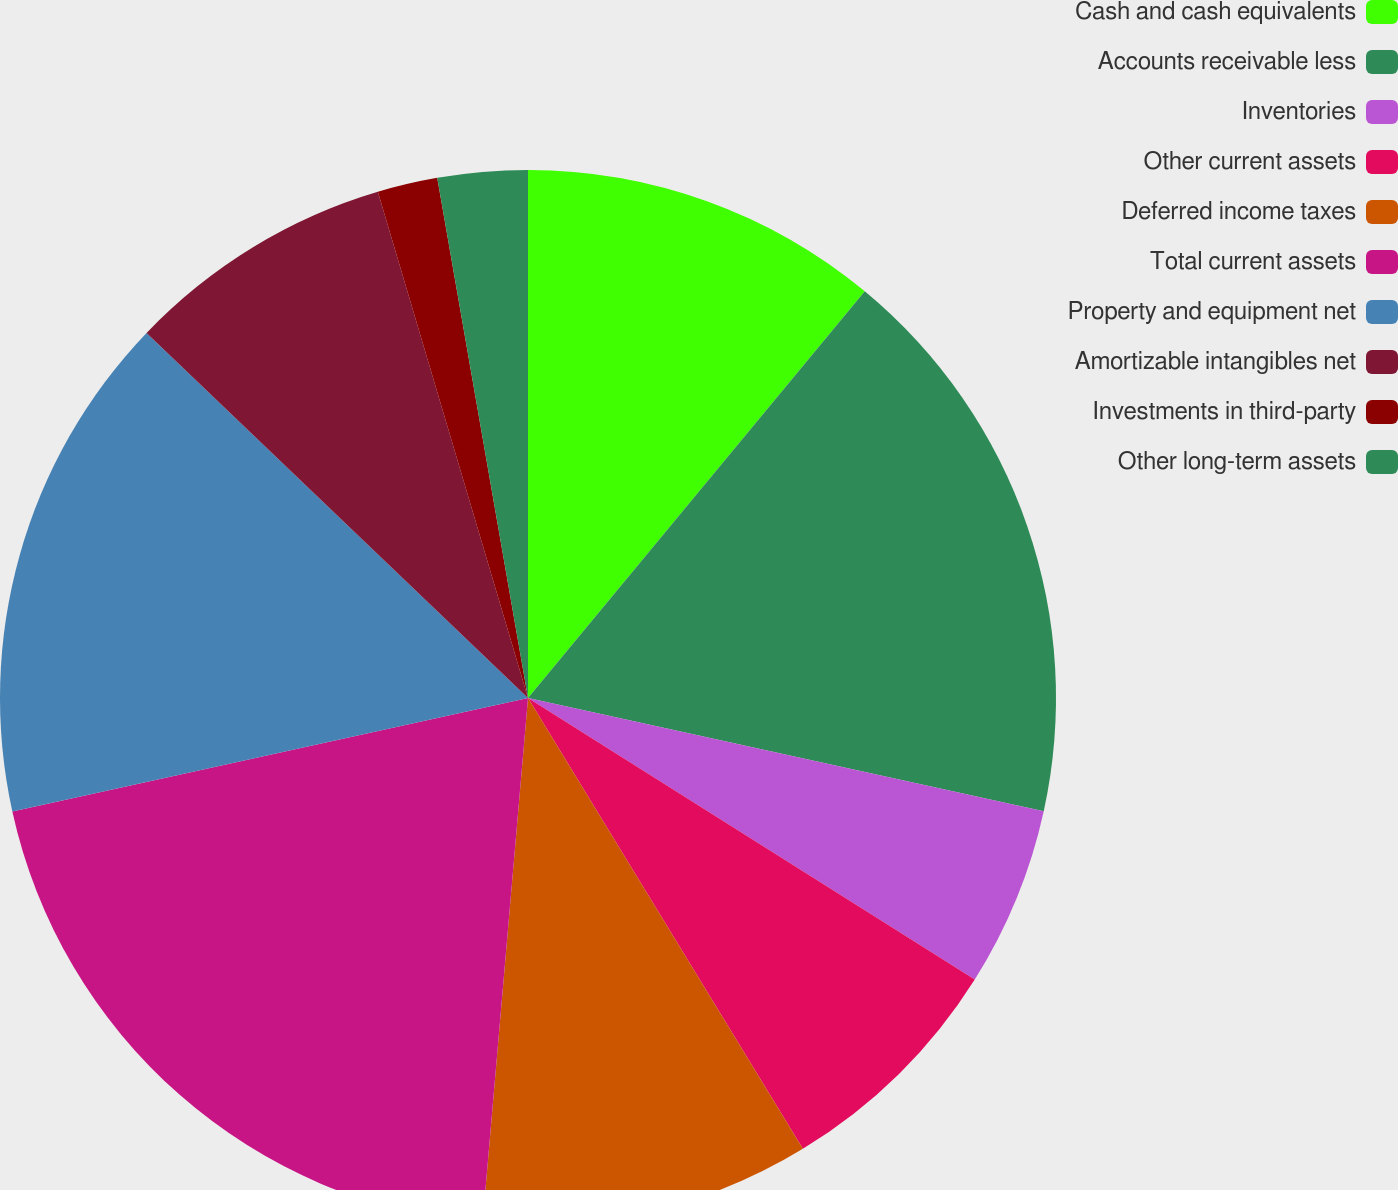<chart> <loc_0><loc_0><loc_500><loc_500><pie_chart><fcel>Cash and cash equivalents<fcel>Accounts receivable less<fcel>Inventories<fcel>Other current assets<fcel>Deferred income taxes<fcel>Total current assets<fcel>Property and equipment net<fcel>Amortizable intangibles net<fcel>Investments in third-party<fcel>Other long-term assets<nl><fcel>11.01%<fcel>17.43%<fcel>5.51%<fcel>7.34%<fcel>10.09%<fcel>20.18%<fcel>15.6%<fcel>8.26%<fcel>1.84%<fcel>2.75%<nl></chart> 